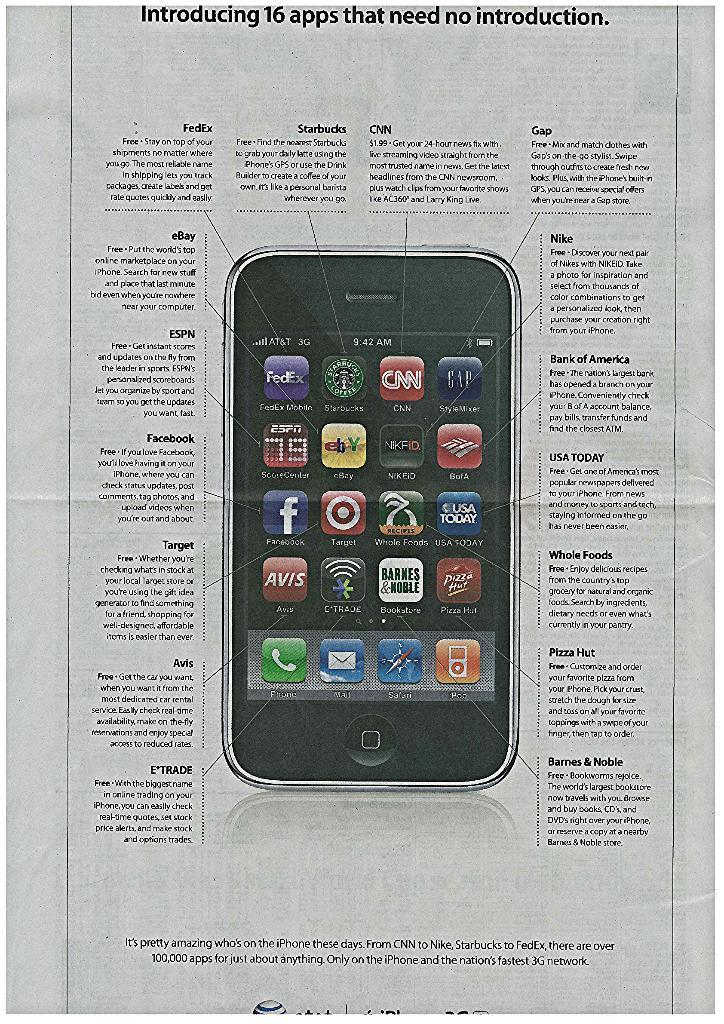<image>
Relay a brief, clear account of the picture shown. A paper introducing 16 apps that need no introduction 